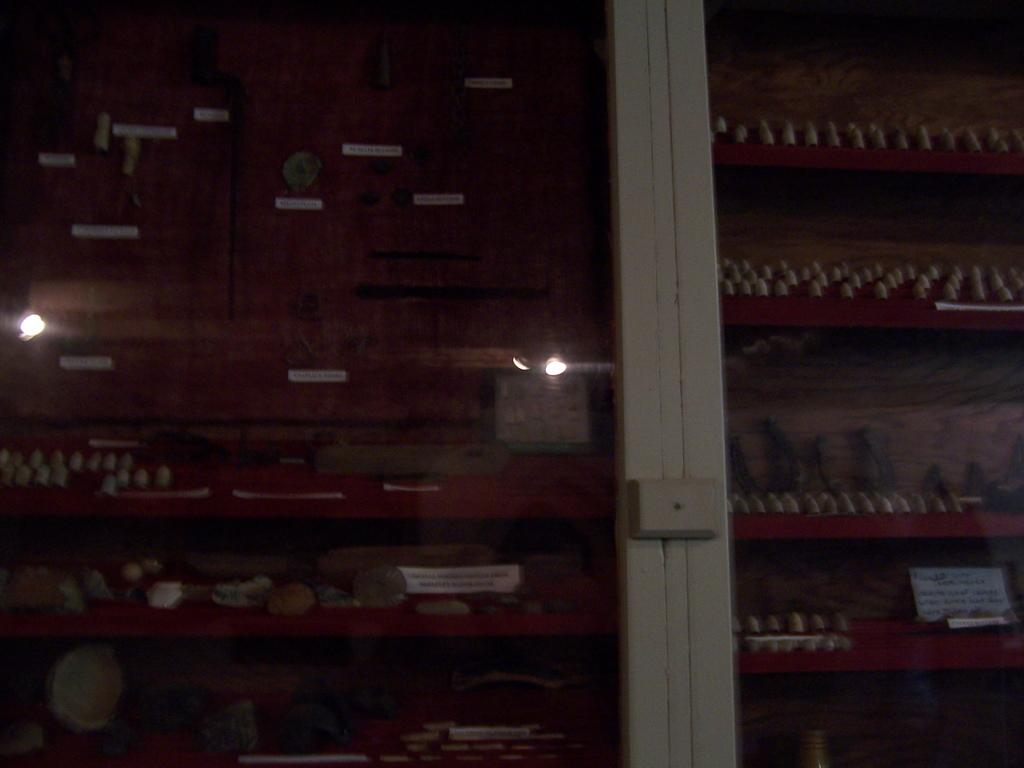What is present in the image that can hold items? There is a rack in the image that can hold items. What type of item is on the rack? A: There is a food item on the rack. What can be seen in front of the rack? There is a light visible in front of the rack. What does the police officer's son say about the food item on the rack? There is no police officer or son present in the image, so we cannot answer this question. 